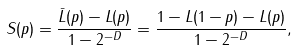Convert formula to latex. <formula><loc_0><loc_0><loc_500><loc_500>S ( p ) = \frac { \bar { L } ( p ) - L ( p ) } { 1 - 2 ^ { - D } } = \frac { 1 - L ( 1 - p ) - L ( p ) } { 1 - 2 ^ { - D } } ,</formula> 